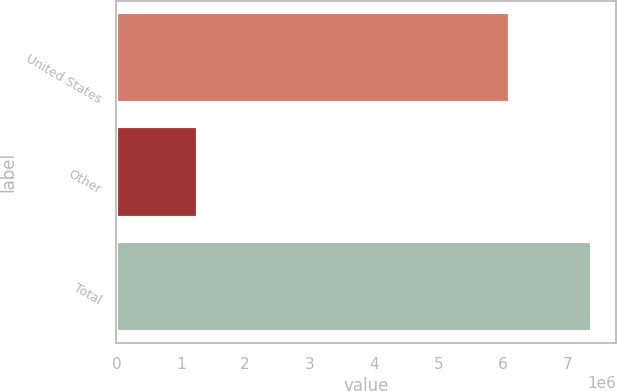Convert chart to OTSL. <chart><loc_0><loc_0><loc_500><loc_500><bar_chart><fcel>United States<fcel>Other<fcel>Total<nl><fcel>6.11649e+06<fcel>1.27014e+06<fcel>7.38663e+06<nl></chart> 